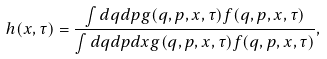<formula> <loc_0><loc_0><loc_500><loc_500>h ( x , \tau ) & = \frac { \int d q d p g ( q , p , x , \tau ) f ( q , p , x , \tau ) } { \int d q d p d x g ( q , p , x , \tau ) f ( q , p , x , \tau ) } ,</formula> 